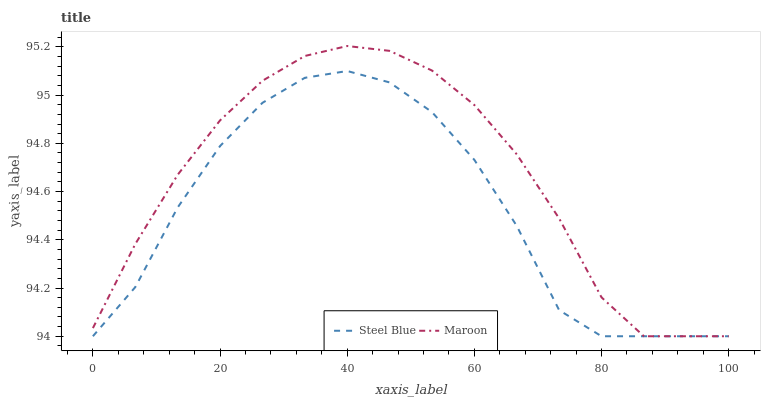Does Steel Blue have the minimum area under the curve?
Answer yes or no. Yes. Does Maroon have the maximum area under the curve?
Answer yes or no. Yes. Does Maroon have the minimum area under the curve?
Answer yes or no. No. Is Maroon the smoothest?
Answer yes or no. Yes. Is Steel Blue the roughest?
Answer yes or no. Yes. Is Maroon the roughest?
Answer yes or no. No. Does Steel Blue have the lowest value?
Answer yes or no. Yes. Does Maroon have the highest value?
Answer yes or no. Yes. Does Steel Blue intersect Maroon?
Answer yes or no. Yes. Is Steel Blue less than Maroon?
Answer yes or no. No. Is Steel Blue greater than Maroon?
Answer yes or no. No. 